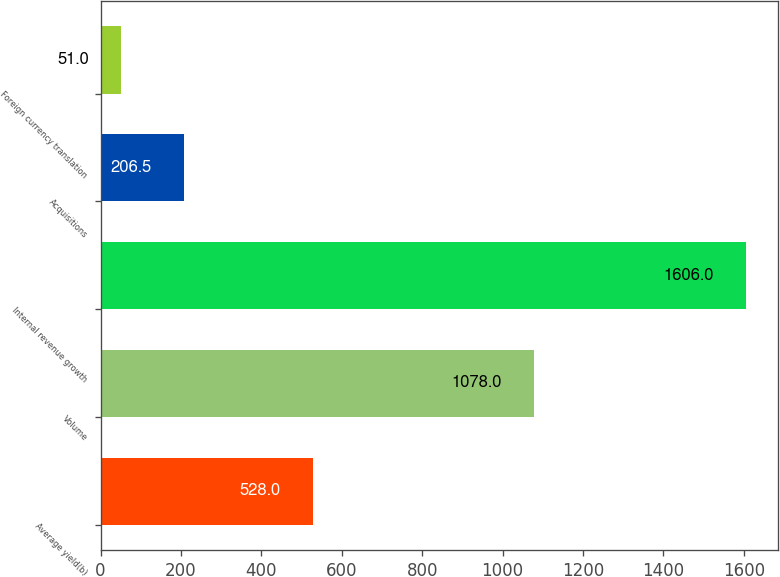Convert chart to OTSL. <chart><loc_0><loc_0><loc_500><loc_500><bar_chart><fcel>Average yield(b)<fcel>Volume<fcel>Internal revenue growth<fcel>Acquisitions<fcel>Foreign currency translation<nl><fcel>528<fcel>1078<fcel>1606<fcel>206.5<fcel>51<nl></chart> 